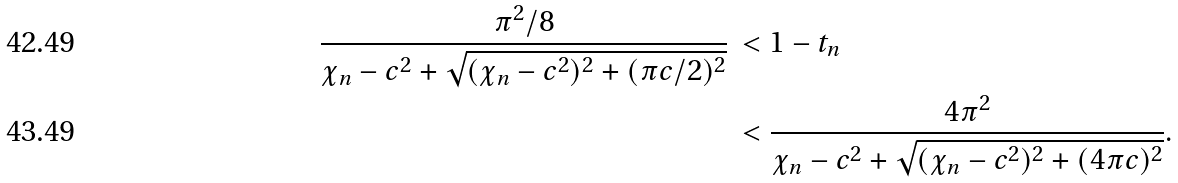<formula> <loc_0><loc_0><loc_500><loc_500>\frac { \pi ^ { 2 } / 8 } { \chi _ { n } - c ^ { 2 } + \sqrt { ( \chi _ { n } - c ^ { 2 } ) ^ { 2 } + ( \pi c / 2 ) ^ { 2 } } } & \, < 1 - t _ { n } \\ & \, < \frac { 4 \pi ^ { 2 } } { \chi _ { n } - c ^ { 2 } + \sqrt { ( \chi _ { n } - c ^ { 2 } ) ^ { 2 } + ( 4 \pi c ) ^ { 2 } } } .</formula> 